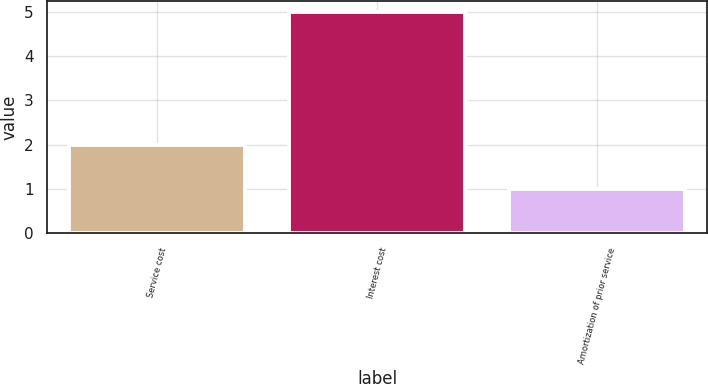Convert chart. <chart><loc_0><loc_0><loc_500><loc_500><bar_chart><fcel>Service cost<fcel>Interest cost<fcel>Amortization of prior service<nl><fcel>2<fcel>5<fcel>1<nl></chart> 